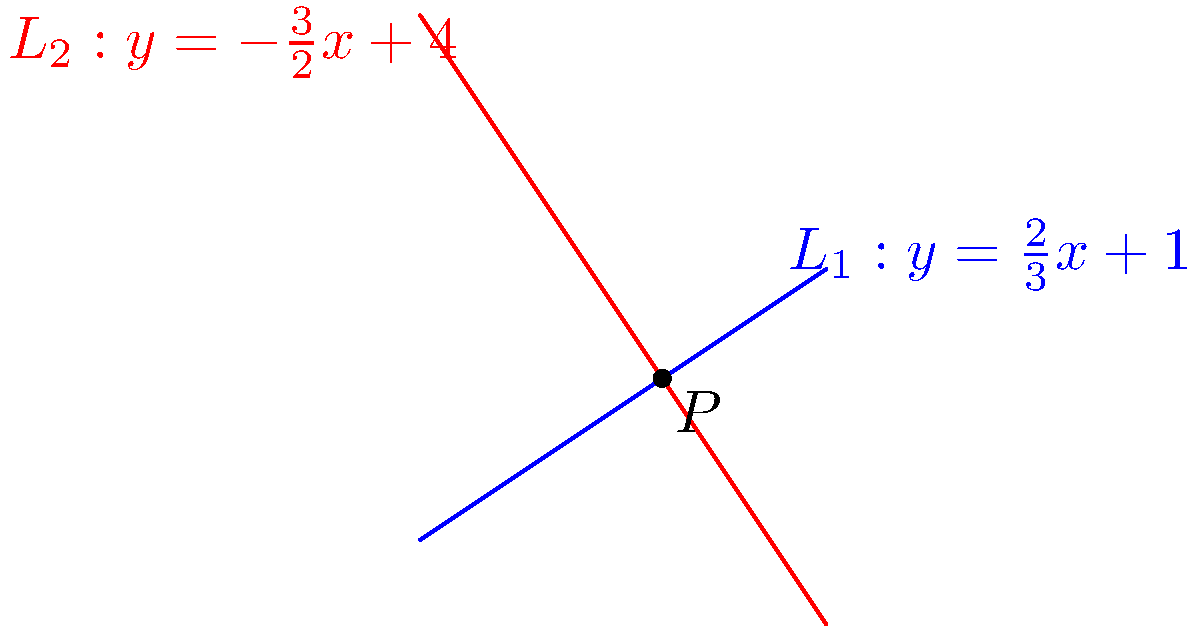In the Cartesian plane, two lines $L_1$ and $L_2$ are given by the equations $y = \frac{2}{3}x + 1$ and $y = -\frac{3}{2}x + 4$ respectively. Calculate the acute angle (in degrees) between these two lines at their point of intersection. Round your answer to the nearest whole number. To find the angle between two intersecting lines, we can use the following steps:

1) The general formula for the angle $\theta$ between two lines with slopes $m_1$ and $m_2$ is:

   $$\tan \theta = \left|\frac{m_1 - m_2}{1 + m_1m_2}\right|$$

2) From the given equations, we can identify the slopes:
   $L_1: m_1 = \frac{2}{3}$
   $L_2: m_2 = -\frac{3}{2}$

3) Substituting these values into the formula:

   $$\tan \theta = \left|\frac{\frac{2}{3} - (-\frac{3}{2})}{1 + \frac{2}{3}(-\frac{3}{2})}\right|$$

4) Simplify the numerator and denominator:

   $$\tan \theta = \left|\frac{\frac{2}{3} + \frac{3}{2}}{1 - 1}\right| = \left|\frac{\frac{4}{3} + \frac{9}{6}}{0}\right| = \left|\frac{\frac{8+9}{6}}{0}\right| = \left|\frac{\frac{17}{6}}{0}\right|$$

5) This results in an undefined value, which means the angle is 90°.

6) We can verify this by observing that the product of the slopes is -1:

   $$m_1 \cdot m_2 = \frac{2}{3} \cdot (-\frac{3}{2}) = -1$$

   When the product of the slopes of two lines is -1, the lines are perpendicular.

7) Therefore, the acute angle between the lines is 90°.
Answer: 90° 